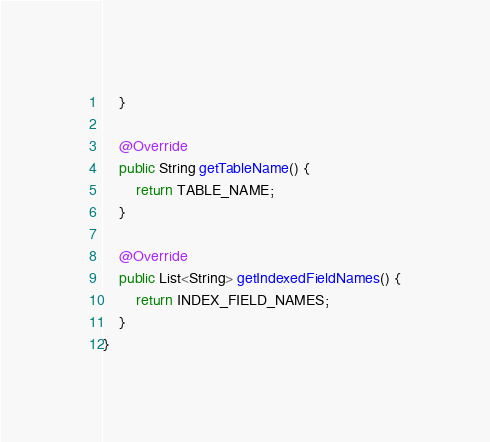Convert code to text. <code><loc_0><loc_0><loc_500><loc_500><_Java_>    }

    @Override
    public String getTableName() {
        return TABLE_NAME;
    }

    @Override
    public List<String> getIndexedFieldNames() {
        return INDEX_FIELD_NAMES;
    }
}
</code> 